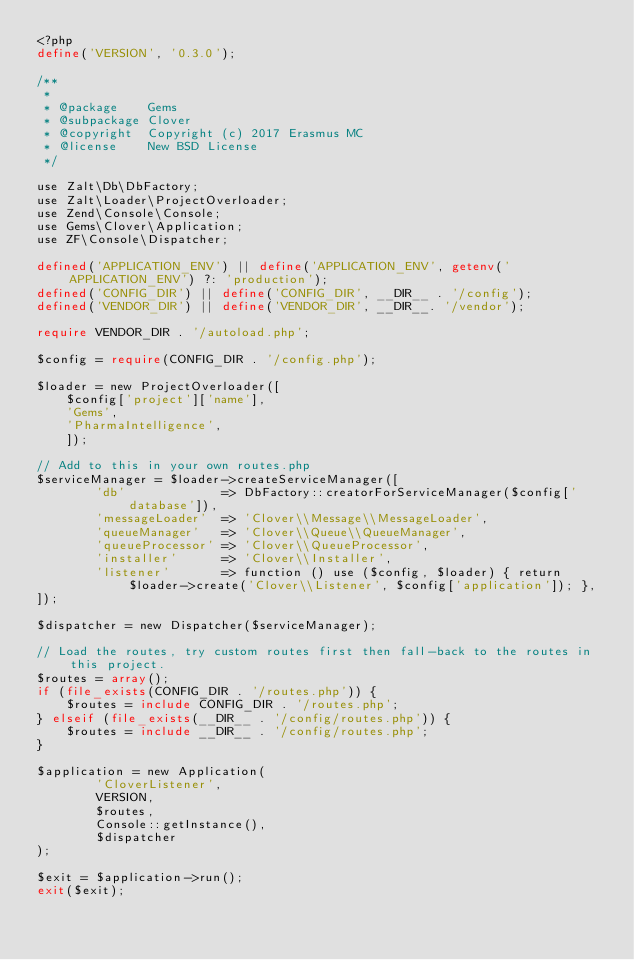Convert code to text. <code><loc_0><loc_0><loc_500><loc_500><_PHP_><?php
define('VERSION', '0.3.0');

/**
 *
 * @package    Gems
 * @subpackage Clover
 * @copyright  Copyright (c) 2017 Erasmus MC
 * @license    New BSD License
 */

use Zalt\Db\DbFactory;
use Zalt\Loader\ProjectOverloader;
use Zend\Console\Console;
use Gems\Clover\Application;
use ZF\Console\Dispatcher;

defined('APPLICATION_ENV') || define('APPLICATION_ENV', getenv('APPLICATION_ENV') ?: 'production');
defined('CONFIG_DIR') || define('CONFIG_DIR', __DIR__ . '/config');
defined('VENDOR_DIR') || define('VENDOR_DIR', __DIR__. '/vendor');

require VENDOR_DIR . '/autoload.php';

$config = require(CONFIG_DIR . '/config.php');

$loader = new ProjectOverloader([
    $config['project']['name'],
    'Gems',
    'PharmaIntelligence',
    ]);

// Add to this in your own routes.php
$serviceManager = $loader->createServiceManager([
        'db'             => DbFactory::creatorForServiceManager($config['database']),
        'messageLoader'  => 'Clover\\Message\\MessageLoader',
        'queueManager'   => 'Clover\\Queue\\QueueManager',
        'queueProcessor' => 'Clover\\QueueProcessor',
        'installer'      => 'Clover\\Installer',
        'listener'       => function () use ($config, $loader) { return $loader->create('Clover\\Listener', $config['application']); },
]);

$dispatcher = new Dispatcher($serviceManager);

// Load the routes, try custom routes first then fall-back to the routes in this project.
$routes = array();
if (file_exists(CONFIG_DIR . '/routes.php')) {
    $routes = include CONFIG_DIR . '/routes.php';
} elseif (file_exists(__DIR__ . '/config/routes.php')) {
    $routes = include __DIR__ . '/config/routes.php';
}

$application = new Application(
        'CloverListener', 
        VERSION, 
        $routes, 
        Console::getInstance(), 
        $dispatcher
);

$exit = $application->run();
exit($exit);
</code> 